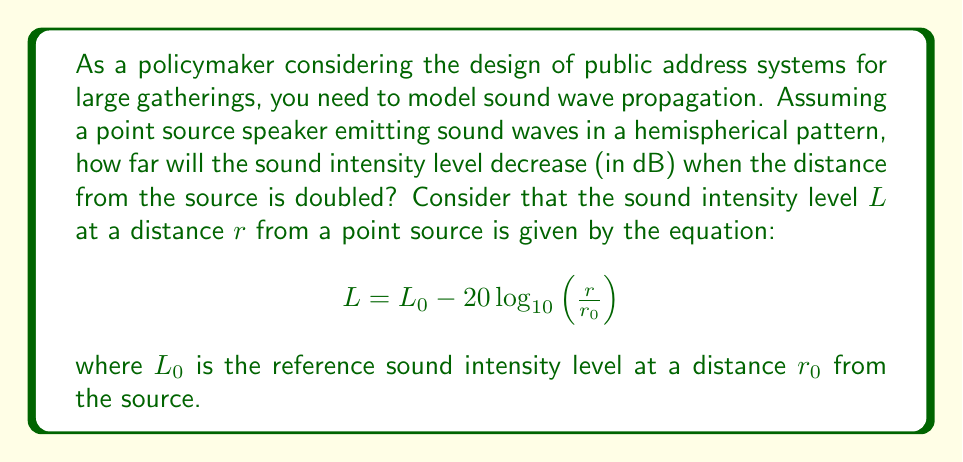Could you help me with this problem? Let's approach this step-by-step:

1) We are given the equation for sound intensity level:
   $$ L = L_0 - 20 \log_{10}\left(\frac{r}{r_0}\right) $$

2) We want to find the difference in sound intensity level when the distance is doubled. Let's call the initial distance $r_1$ and the doubled distance $r_2 = 2r_1$.

3) The sound intensity level at $r_1$ is:
   $$ L_1 = L_0 - 20 \log_{10}\left(\frac{r_1}{r_0}\right) $$

4) The sound intensity level at $r_2$ is:
   $$ L_2 = L_0 - 20 \log_{10}\left(\frac{r_2}{r_0}\right) = L_0 - 20 \log_{10}\left(\frac{2r_1}{r_0}\right) $$

5) The decrease in sound intensity level is $L_1 - L_2$:
   $$ \begin{align}
   L_1 - L_2 &= \left[L_0 - 20 \log_{10}\left(\frac{r_1}{r_0}\right)\right] - \left[L_0 - 20 \log_{10}\left(\frac{2r_1}{r_0}\right)\right] \\
   &= 20 \log_{10}\left(\frac{2r_1}{r_0}\right) - 20 \log_{10}\left(\frac{r_1}{r_0}\right) \\
   &= 20 \log_{10}(2) \\
   &= 20 \cdot 0.301 \\
   &= 6.02 \text{ dB}
   \end{align} $$

6) Therefore, when the distance from the source is doubled, the sound intensity level decreases by approximately 6.02 dB.
Answer: 6.02 dB 